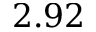<formula> <loc_0><loc_0><loc_500><loc_500>2 . 9 2</formula> 